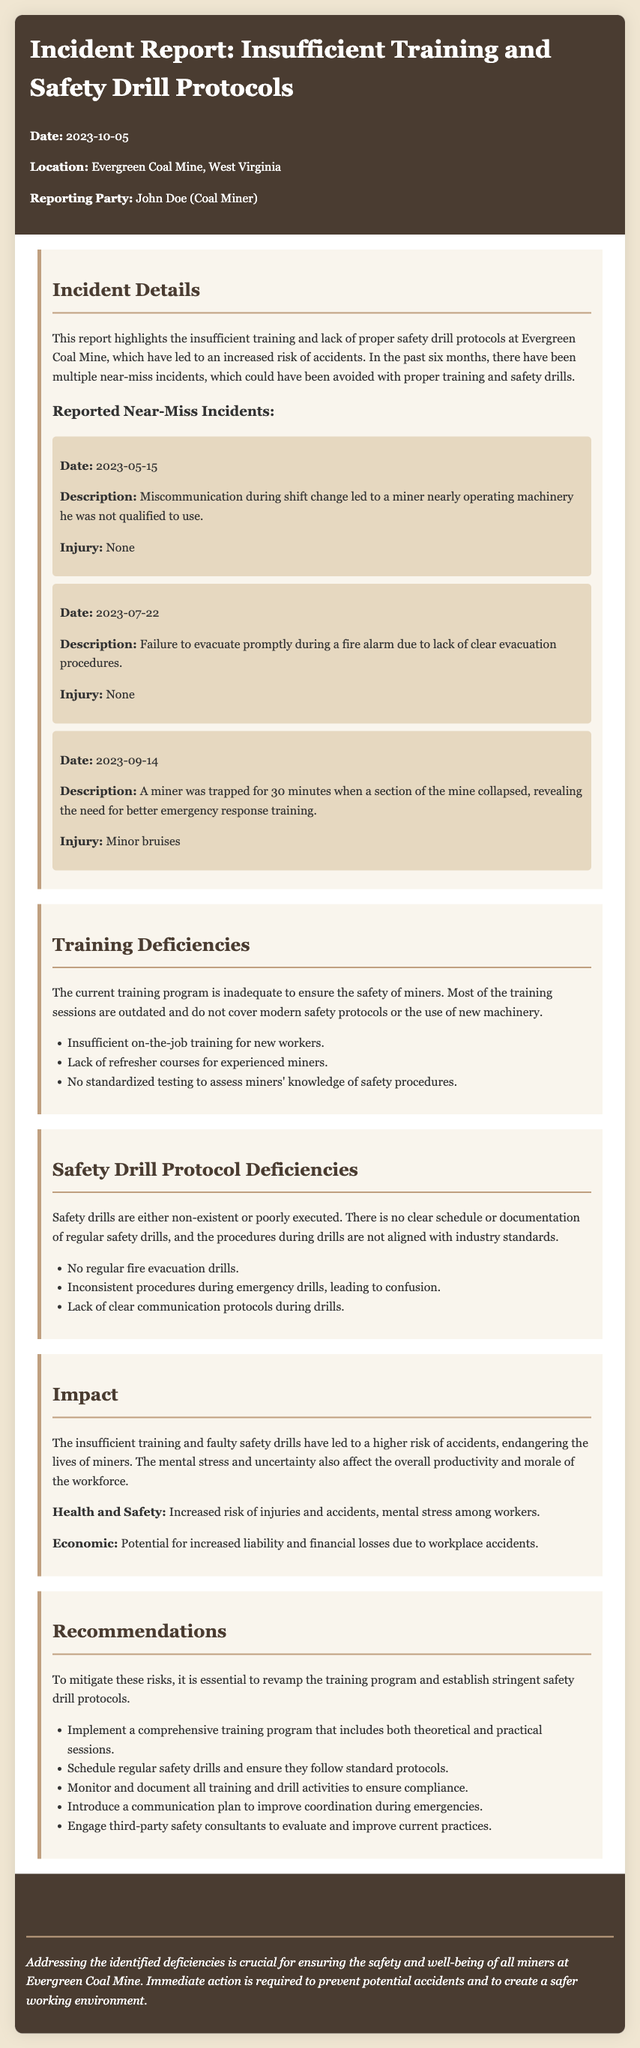what is the date of the incident report? The date of the incident report is stated in the document as 2023-10-05.
Answer: 2023-10-05 who reported the incident? The incident report indicates that John Doe reported the incident.
Answer: John Doe how many near-miss incidents are mentioned? The document states that there have been multiple near-miss incidents, with three specific cases detailed in the report.
Answer: three what is one training deficiency identified in the report? The report lists several deficiencies, one being insufficient on-the-job training for new workers.
Answer: insufficient on-the-job training for new workers what are the potential economic impacts mentioned in the report? The document states that potential economic impacts include increased liability and financial losses due to workplace accidents.
Answer: increased liability and financial losses what is the recommendation for improving training? The report recommends implementing a comprehensive training program that includes both theoretical and practical sessions.
Answer: comprehensive training program what was the injury result from the near-miss incident on 2023-09-14? The near-miss incident on 2023-09-14 resulted in minor bruises.
Answer: minor bruises how many recommendations are provided in the report? The document lists five recommendations aimed at improving safety and training protocols.
Answer: five what is a reason for the mental stress mentioned in the impact section? The report states that insufficient training and faulty safety drills have led to higher risk of accidents, causing mental stress among workers.
Answer: higher risk of accidents 